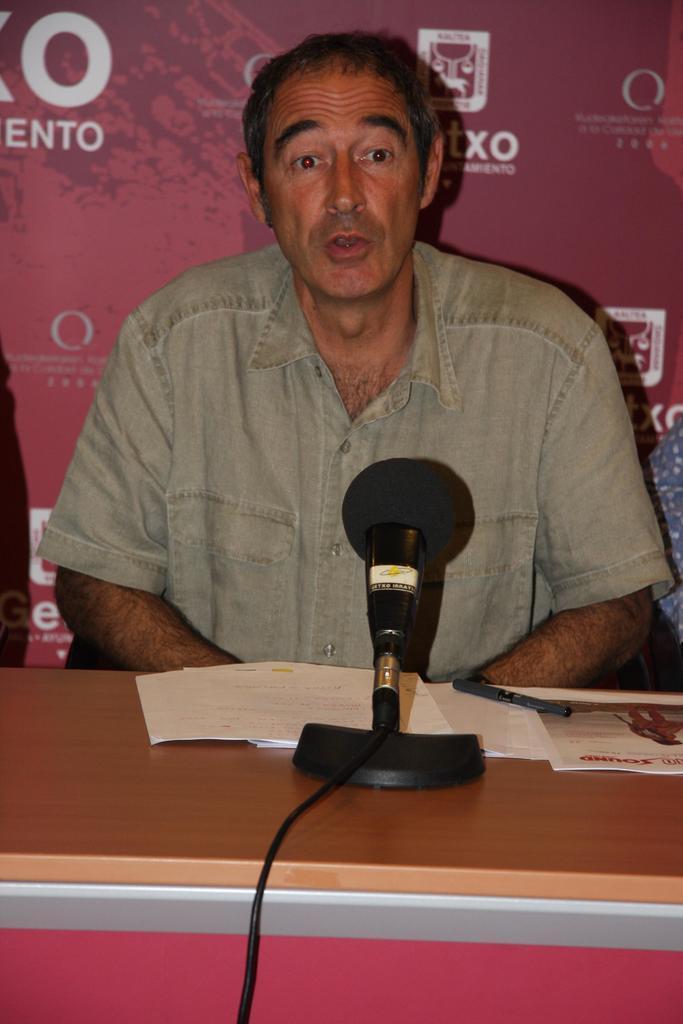Can you describe this image briefly? We can see the person is sitting in a chair. There is a table. There is a mic,paper and wire on a table. His talking we can see his mouth is open. 